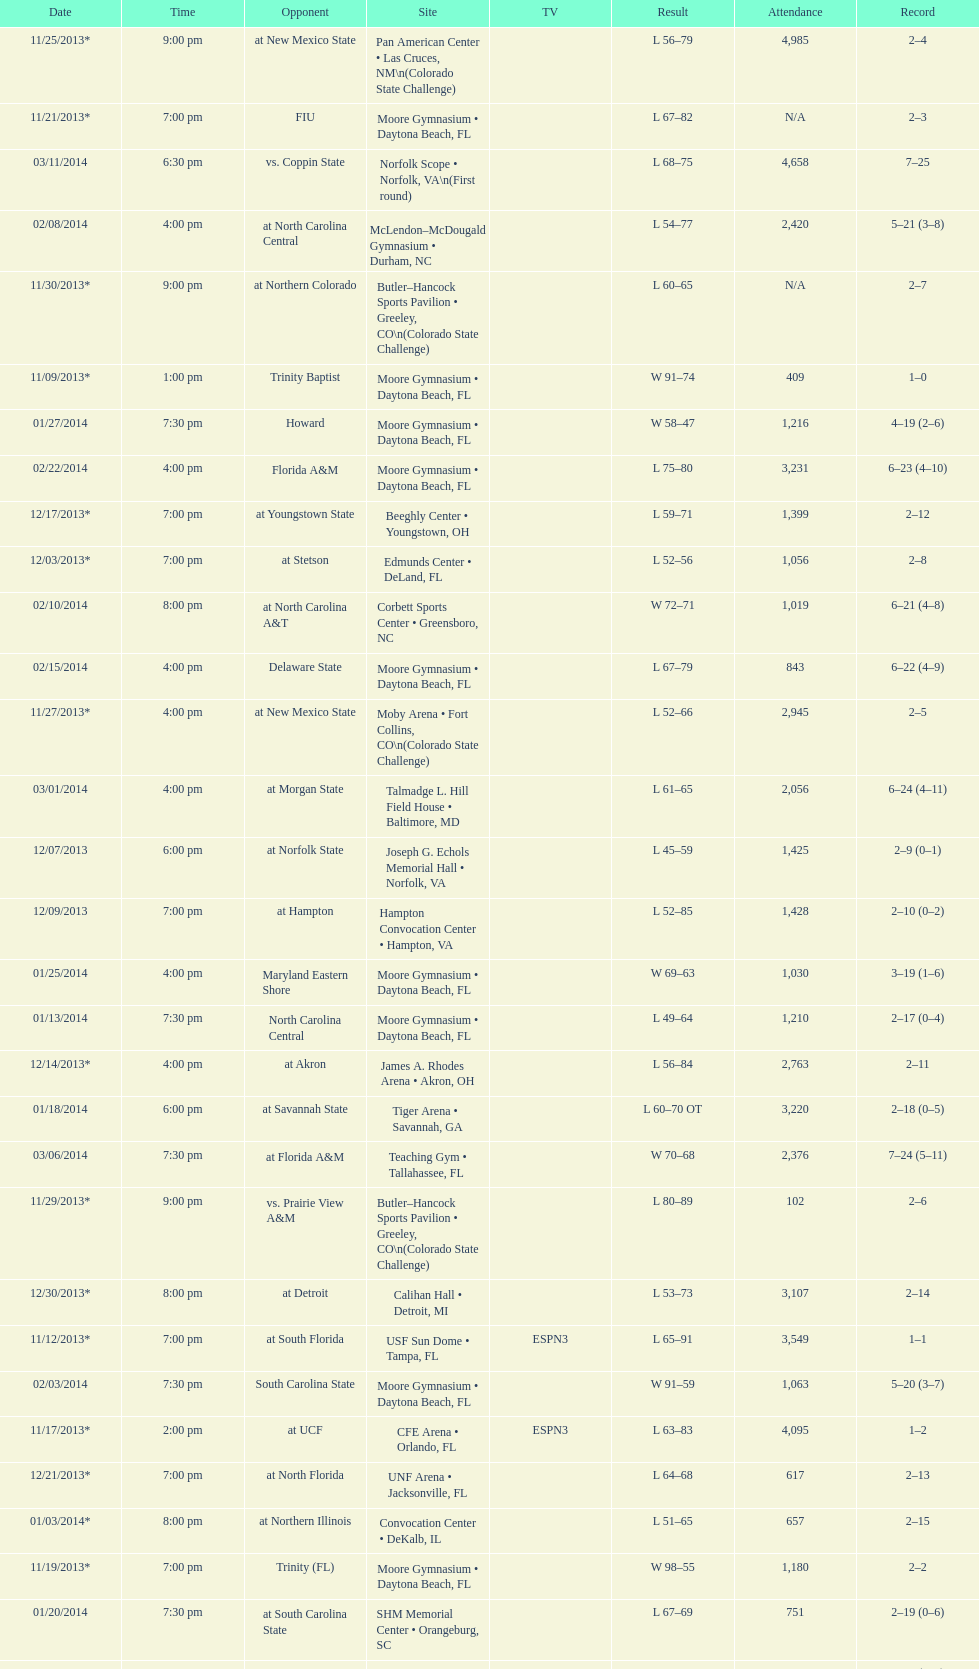How much larger was the attendance on 11/25/2013 than 12/21/2013? 4368. 